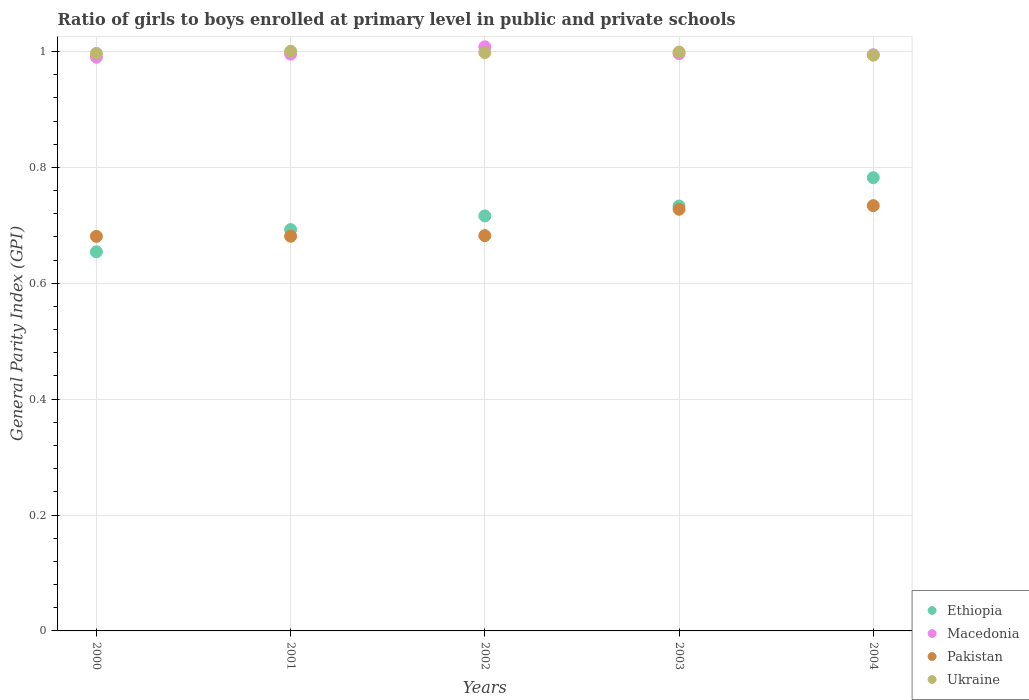Is the number of dotlines equal to the number of legend labels?
Offer a very short reply. Yes. What is the general parity index in Pakistan in 2004?
Provide a short and direct response. 0.73. Across all years, what is the maximum general parity index in Pakistan?
Your answer should be very brief. 0.73. Across all years, what is the minimum general parity index in Pakistan?
Provide a succinct answer. 0.68. In which year was the general parity index in Ethiopia maximum?
Ensure brevity in your answer.  2004. In which year was the general parity index in Pakistan minimum?
Make the answer very short. 2000. What is the total general parity index in Ethiopia in the graph?
Ensure brevity in your answer.  3.58. What is the difference between the general parity index in Ethiopia in 2000 and that in 2003?
Provide a short and direct response. -0.08. What is the difference between the general parity index in Macedonia in 2002 and the general parity index in Ethiopia in 2003?
Offer a very short reply. 0.27. What is the average general parity index in Ethiopia per year?
Your answer should be compact. 0.72. In the year 2001, what is the difference between the general parity index in Ethiopia and general parity index in Macedonia?
Provide a short and direct response. -0.3. What is the ratio of the general parity index in Ethiopia in 2000 to that in 2001?
Offer a terse response. 0.94. Is the difference between the general parity index in Ethiopia in 2000 and 2004 greater than the difference between the general parity index in Macedonia in 2000 and 2004?
Offer a terse response. No. What is the difference between the highest and the second highest general parity index in Macedonia?
Offer a very short reply. 0.01. What is the difference between the highest and the lowest general parity index in Pakistan?
Ensure brevity in your answer.  0.05. Is it the case that in every year, the sum of the general parity index in Pakistan and general parity index in Macedonia  is greater than the sum of general parity index in Ukraine and general parity index in Ethiopia?
Make the answer very short. No. Is the general parity index in Pakistan strictly greater than the general parity index in Macedonia over the years?
Your response must be concise. No. Is the general parity index in Ethiopia strictly less than the general parity index in Pakistan over the years?
Your answer should be compact. No. How many dotlines are there?
Your response must be concise. 4. What is the difference between two consecutive major ticks on the Y-axis?
Your response must be concise. 0.2. Where does the legend appear in the graph?
Your response must be concise. Bottom right. How many legend labels are there?
Ensure brevity in your answer.  4. How are the legend labels stacked?
Make the answer very short. Vertical. What is the title of the graph?
Offer a very short reply. Ratio of girls to boys enrolled at primary level in public and private schools. Does "Comoros" appear as one of the legend labels in the graph?
Your response must be concise. No. What is the label or title of the X-axis?
Make the answer very short. Years. What is the label or title of the Y-axis?
Offer a very short reply. General Parity Index (GPI). What is the General Parity Index (GPI) of Ethiopia in 2000?
Give a very brief answer. 0.65. What is the General Parity Index (GPI) in Macedonia in 2000?
Keep it short and to the point. 0.99. What is the General Parity Index (GPI) of Pakistan in 2000?
Offer a very short reply. 0.68. What is the General Parity Index (GPI) in Ukraine in 2000?
Ensure brevity in your answer.  1. What is the General Parity Index (GPI) of Ethiopia in 2001?
Keep it short and to the point. 0.69. What is the General Parity Index (GPI) of Macedonia in 2001?
Make the answer very short. 1. What is the General Parity Index (GPI) in Pakistan in 2001?
Your response must be concise. 0.68. What is the General Parity Index (GPI) in Ukraine in 2001?
Your answer should be very brief. 1. What is the General Parity Index (GPI) of Ethiopia in 2002?
Offer a terse response. 0.72. What is the General Parity Index (GPI) in Macedonia in 2002?
Your answer should be compact. 1.01. What is the General Parity Index (GPI) in Pakistan in 2002?
Provide a succinct answer. 0.68. What is the General Parity Index (GPI) in Ukraine in 2002?
Provide a succinct answer. 1. What is the General Parity Index (GPI) of Ethiopia in 2003?
Keep it short and to the point. 0.73. What is the General Parity Index (GPI) of Macedonia in 2003?
Your answer should be compact. 1. What is the General Parity Index (GPI) of Pakistan in 2003?
Give a very brief answer. 0.73. What is the General Parity Index (GPI) in Ukraine in 2003?
Ensure brevity in your answer.  1. What is the General Parity Index (GPI) in Ethiopia in 2004?
Make the answer very short. 0.78. What is the General Parity Index (GPI) in Macedonia in 2004?
Keep it short and to the point. 0.99. What is the General Parity Index (GPI) in Pakistan in 2004?
Your response must be concise. 0.73. What is the General Parity Index (GPI) in Ukraine in 2004?
Your answer should be compact. 0.99. Across all years, what is the maximum General Parity Index (GPI) in Ethiopia?
Ensure brevity in your answer.  0.78. Across all years, what is the maximum General Parity Index (GPI) in Macedonia?
Your answer should be very brief. 1.01. Across all years, what is the maximum General Parity Index (GPI) in Pakistan?
Make the answer very short. 0.73. Across all years, what is the maximum General Parity Index (GPI) in Ukraine?
Provide a succinct answer. 1. Across all years, what is the minimum General Parity Index (GPI) of Ethiopia?
Ensure brevity in your answer.  0.65. Across all years, what is the minimum General Parity Index (GPI) in Macedonia?
Offer a terse response. 0.99. Across all years, what is the minimum General Parity Index (GPI) in Pakistan?
Offer a very short reply. 0.68. Across all years, what is the minimum General Parity Index (GPI) in Ukraine?
Give a very brief answer. 0.99. What is the total General Parity Index (GPI) in Ethiopia in the graph?
Ensure brevity in your answer.  3.58. What is the total General Parity Index (GPI) of Macedonia in the graph?
Make the answer very short. 4.98. What is the total General Parity Index (GPI) of Pakistan in the graph?
Provide a short and direct response. 3.51. What is the total General Parity Index (GPI) of Ukraine in the graph?
Provide a succinct answer. 4.99. What is the difference between the General Parity Index (GPI) of Ethiopia in 2000 and that in 2001?
Provide a succinct answer. -0.04. What is the difference between the General Parity Index (GPI) in Macedonia in 2000 and that in 2001?
Make the answer very short. -0.01. What is the difference between the General Parity Index (GPI) in Pakistan in 2000 and that in 2001?
Provide a succinct answer. -0. What is the difference between the General Parity Index (GPI) in Ukraine in 2000 and that in 2001?
Provide a succinct answer. -0. What is the difference between the General Parity Index (GPI) in Ethiopia in 2000 and that in 2002?
Make the answer very short. -0.06. What is the difference between the General Parity Index (GPI) in Macedonia in 2000 and that in 2002?
Keep it short and to the point. -0.02. What is the difference between the General Parity Index (GPI) of Pakistan in 2000 and that in 2002?
Your answer should be compact. -0. What is the difference between the General Parity Index (GPI) of Ukraine in 2000 and that in 2002?
Offer a terse response. -0. What is the difference between the General Parity Index (GPI) in Ethiopia in 2000 and that in 2003?
Provide a succinct answer. -0.08. What is the difference between the General Parity Index (GPI) of Macedonia in 2000 and that in 2003?
Offer a terse response. -0.01. What is the difference between the General Parity Index (GPI) in Pakistan in 2000 and that in 2003?
Provide a short and direct response. -0.05. What is the difference between the General Parity Index (GPI) in Ukraine in 2000 and that in 2003?
Make the answer very short. -0. What is the difference between the General Parity Index (GPI) in Ethiopia in 2000 and that in 2004?
Your answer should be compact. -0.13. What is the difference between the General Parity Index (GPI) in Macedonia in 2000 and that in 2004?
Provide a succinct answer. -0. What is the difference between the General Parity Index (GPI) of Pakistan in 2000 and that in 2004?
Offer a very short reply. -0.05. What is the difference between the General Parity Index (GPI) of Ukraine in 2000 and that in 2004?
Ensure brevity in your answer.  0. What is the difference between the General Parity Index (GPI) in Ethiopia in 2001 and that in 2002?
Your response must be concise. -0.02. What is the difference between the General Parity Index (GPI) of Macedonia in 2001 and that in 2002?
Provide a short and direct response. -0.01. What is the difference between the General Parity Index (GPI) of Pakistan in 2001 and that in 2002?
Ensure brevity in your answer.  -0. What is the difference between the General Parity Index (GPI) of Ukraine in 2001 and that in 2002?
Give a very brief answer. 0. What is the difference between the General Parity Index (GPI) of Ethiopia in 2001 and that in 2003?
Your response must be concise. -0.04. What is the difference between the General Parity Index (GPI) in Macedonia in 2001 and that in 2003?
Your answer should be very brief. -0. What is the difference between the General Parity Index (GPI) of Pakistan in 2001 and that in 2003?
Make the answer very short. -0.05. What is the difference between the General Parity Index (GPI) of Ukraine in 2001 and that in 2003?
Your answer should be compact. 0. What is the difference between the General Parity Index (GPI) of Ethiopia in 2001 and that in 2004?
Your answer should be very brief. -0.09. What is the difference between the General Parity Index (GPI) in Macedonia in 2001 and that in 2004?
Your response must be concise. 0. What is the difference between the General Parity Index (GPI) in Pakistan in 2001 and that in 2004?
Ensure brevity in your answer.  -0.05. What is the difference between the General Parity Index (GPI) of Ukraine in 2001 and that in 2004?
Provide a succinct answer. 0.01. What is the difference between the General Parity Index (GPI) of Ethiopia in 2002 and that in 2003?
Your answer should be very brief. -0.02. What is the difference between the General Parity Index (GPI) of Macedonia in 2002 and that in 2003?
Make the answer very short. 0.01. What is the difference between the General Parity Index (GPI) in Pakistan in 2002 and that in 2003?
Your answer should be very brief. -0.05. What is the difference between the General Parity Index (GPI) of Ukraine in 2002 and that in 2003?
Offer a terse response. -0. What is the difference between the General Parity Index (GPI) in Ethiopia in 2002 and that in 2004?
Provide a short and direct response. -0.07. What is the difference between the General Parity Index (GPI) of Macedonia in 2002 and that in 2004?
Offer a terse response. 0.01. What is the difference between the General Parity Index (GPI) in Pakistan in 2002 and that in 2004?
Provide a succinct answer. -0.05. What is the difference between the General Parity Index (GPI) in Ukraine in 2002 and that in 2004?
Your response must be concise. 0. What is the difference between the General Parity Index (GPI) of Ethiopia in 2003 and that in 2004?
Make the answer very short. -0.05. What is the difference between the General Parity Index (GPI) of Macedonia in 2003 and that in 2004?
Your answer should be very brief. 0. What is the difference between the General Parity Index (GPI) in Pakistan in 2003 and that in 2004?
Keep it short and to the point. -0.01. What is the difference between the General Parity Index (GPI) of Ukraine in 2003 and that in 2004?
Keep it short and to the point. 0.01. What is the difference between the General Parity Index (GPI) of Ethiopia in 2000 and the General Parity Index (GPI) of Macedonia in 2001?
Offer a terse response. -0.34. What is the difference between the General Parity Index (GPI) of Ethiopia in 2000 and the General Parity Index (GPI) of Pakistan in 2001?
Provide a succinct answer. -0.03. What is the difference between the General Parity Index (GPI) in Ethiopia in 2000 and the General Parity Index (GPI) in Ukraine in 2001?
Provide a succinct answer. -0.35. What is the difference between the General Parity Index (GPI) of Macedonia in 2000 and the General Parity Index (GPI) of Pakistan in 2001?
Offer a terse response. 0.31. What is the difference between the General Parity Index (GPI) in Macedonia in 2000 and the General Parity Index (GPI) in Ukraine in 2001?
Your answer should be compact. -0.01. What is the difference between the General Parity Index (GPI) in Pakistan in 2000 and the General Parity Index (GPI) in Ukraine in 2001?
Make the answer very short. -0.32. What is the difference between the General Parity Index (GPI) in Ethiopia in 2000 and the General Parity Index (GPI) in Macedonia in 2002?
Provide a succinct answer. -0.35. What is the difference between the General Parity Index (GPI) of Ethiopia in 2000 and the General Parity Index (GPI) of Pakistan in 2002?
Provide a short and direct response. -0.03. What is the difference between the General Parity Index (GPI) of Ethiopia in 2000 and the General Parity Index (GPI) of Ukraine in 2002?
Provide a succinct answer. -0.34. What is the difference between the General Parity Index (GPI) of Macedonia in 2000 and the General Parity Index (GPI) of Pakistan in 2002?
Make the answer very short. 0.31. What is the difference between the General Parity Index (GPI) of Macedonia in 2000 and the General Parity Index (GPI) of Ukraine in 2002?
Keep it short and to the point. -0.01. What is the difference between the General Parity Index (GPI) in Pakistan in 2000 and the General Parity Index (GPI) in Ukraine in 2002?
Offer a terse response. -0.32. What is the difference between the General Parity Index (GPI) in Ethiopia in 2000 and the General Parity Index (GPI) in Macedonia in 2003?
Your response must be concise. -0.34. What is the difference between the General Parity Index (GPI) of Ethiopia in 2000 and the General Parity Index (GPI) of Pakistan in 2003?
Provide a succinct answer. -0.07. What is the difference between the General Parity Index (GPI) in Ethiopia in 2000 and the General Parity Index (GPI) in Ukraine in 2003?
Ensure brevity in your answer.  -0.34. What is the difference between the General Parity Index (GPI) of Macedonia in 2000 and the General Parity Index (GPI) of Pakistan in 2003?
Keep it short and to the point. 0.26. What is the difference between the General Parity Index (GPI) in Macedonia in 2000 and the General Parity Index (GPI) in Ukraine in 2003?
Offer a very short reply. -0.01. What is the difference between the General Parity Index (GPI) in Pakistan in 2000 and the General Parity Index (GPI) in Ukraine in 2003?
Your answer should be very brief. -0.32. What is the difference between the General Parity Index (GPI) of Ethiopia in 2000 and the General Parity Index (GPI) of Macedonia in 2004?
Your answer should be compact. -0.34. What is the difference between the General Parity Index (GPI) of Ethiopia in 2000 and the General Parity Index (GPI) of Pakistan in 2004?
Keep it short and to the point. -0.08. What is the difference between the General Parity Index (GPI) of Ethiopia in 2000 and the General Parity Index (GPI) of Ukraine in 2004?
Keep it short and to the point. -0.34. What is the difference between the General Parity Index (GPI) of Macedonia in 2000 and the General Parity Index (GPI) of Pakistan in 2004?
Provide a succinct answer. 0.26. What is the difference between the General Parity Index (GPI) of Macedonia in 2000 and the General Parity Index (GPI) of Ukraine in 2004?
Your response must be concise. -0. What is the difference between the General Parity Index (GPI) in Pakistan in 2000 and the General Parity Index (GPI) in Ukraine in 2004?
Keep it short and to the point. -0.31. What is the difference between the General Parity Index (GPI) in Ethiopia in 2001 and the General Parity Index (GPI) in Macedonia in 2002?
Provide a short and direct response. -0.32. What is the difference between the General Parity Index (GPI) of Ethiopia in 2001 and the General Parity Index (GPI) of Pakistan in 2002?
Offer a very short reply. 0.01. What is the difference between the General Parity Index (GPI) in Ethiopia in 2001 and the General Parity Index (GPI) in Ukraine in 2002?
Give a very brief answer. -0.31. What is the difference between the General Parity Index (GPI) in Macedonia in 2001 and the General Parity Index (GPI) in Pakistan in 2002?
Offer a very short reply. 0.31. What is the difference between the General Parity Index (GPI) in Macedonia in 2001 and the General Parity Index (GPI) in Ukraine in 2002?
Your answer should be compact. -0. What is the difference between the General Parity Index (GPI) in Pakistan in 2001 and the General Parity Index (GPI) in Ukraine in 2002?
Keep it short and to the point. -0.32. What is the difference between the General Parity Index (GPI) of Ethiopia in 2001 and the General Parity Index (GPI) of Macedonia in 2003?
Your response must be concise. -0.3. What is the difference between the General Parity Index (GPI) in Ethiopia in 2001 and the General Parity Index (GPI) in Pakistan in 2003?
Your answer should be compact. -0.04. What is the difference between the General Parity Index (GPI) of Ethiopia in 2001 and the General Parity Index (GPI) of Ukraine in 2003?
Your response must be concise. -0.31. What is the difference between the General Parity Index (GPI) of Macedonia in 2001 and the General Parity Index (GPI) of Pakistan in 2003?
Offer a terse response. 0.27. What is the difference between the General Parity Index (GPI) in Macedonia in 2001 and the General Parity Index (GPI) in Ukraine in 2003?
Your answer should be very brief. -0. What is the difference between the General Parity Index (GPI) in Pakistan in 2001 and the General Parity Index (GPI) in Ukraine in 2003?
Offer a very short reply. -0.32. What is the difference between the General Parity Index (GPI) of Ethiopia in 2001 and the General Parity Index (GPI) of Macedonia in 2004?
Provide a succinct answer. -0.3. What is the difference between the General Parity Index (GPI) in Ethiopia in 2001 and the General Parity Index (GPI) in Pakistan in 2004?
Offer a very short reply. -0.04. What is the difference between the General Parity Index (GPI) in Ethiopia in 2001 and the General Parity Index (GPI) in Ukraine in 2004?
Give a very brief answer. -0.3. What is the difference between the General Parity Index (GPI) in Macedonia in 2001 and the General Parity Index (GPI) in Pakistan in 2004?
Your answer should be very brief. 0.26. What is the difference between the General Parity Index (GPI) in Macedonia in 2001 and the General Parity Index (GPI) in Ukraine in 2004?
Give a very brief answer. 0. What is the difference between the General Parity Index (GPI) of Pakistan in 2001 and the General Parity Index (GPI) of Ukraine in 2004?
Give a very brief answer. -0.31. What is the difference between the General Parity Index (GPI) in Ethiopia in 2002 and the General Parity Index (GPI) in Macedonia in 2003?
Your answer should be very brief. -0.28. What is the difference between the General Parity Index (GPI) in Ethiopia in 2002 and the General Parity Index (GPI) in Pakistan in 2003?
Provide a short and direct response. -0.01. What is the difference between the General Parity Index (GPI) in Ethiopia in 2002 and the General Parity Index (GPI) in Ukraine in 2003?
Make the answer very short. -0.28. What is the difference between the General Parity Index (GPI) of Macedonia in 2002 and the General Parity Index (GPI) of Pakistan in 2003?
Your answer should be compact. 0.28. What is the difference between the General Parity Index (GPI) of Macedonia in 2002 and the General Parity Index (GPI) of Ukraine in 2003?
Keep it short and to the point. 0.01. What is the difference between the General Parity Index (GPI) in Pakistan in 2002 and the General Parity Index (GPI) in Ukraine in 2003?
Your answer should be compact. -0.32. What is the difference between the General Parity Index (GPI) in Ethiopia in 2002 and the General Parity Index (GPI) in Macedonia in 2004?
Your response must be concise. -0.28. What is the difference between the General Parity Index (GPI) in Ethiopia in 2002 and the General Parity Index (GPI) in Pakistan in 2004?
Your response must be concise. -0.02. What is the difference between the General Parity Index (GPI) in Ethiopia in 2002 and the General Parity Index (GPI) in Ukraine in 2004?
Give a very brief answer. -0.28. What is the difference between the General Parity Index (GPI) of Macedonia in 2002 and the General Parity Index (GPI) of Pakistan in 2004?
Offer a very short reply. 0.27. What is the difference between the General Parity Index (GPI) of Macedonia in 2002 and the General Parity Index (GPI) of Ukraine in 2004?
Make the answer very short. 0.01. What is the difference between the General Parity Index (GPI) of Pakistan in 2002 and the General Parity Index (GPI) of Ukraine in 2004?
Give a very brief answer. -0.31. What is the difference between the General Parity Index (GPI) of Ethiopia in 2003 and the General Parity Index (GPI) of Macedonia in 2004?
Your response must be concise. -0.26. What is the difference between the General Parity Index (GPI) in Ethiopia in 2003 and the General Parity Index (GPI) in Pakistan in 2004?
Provide a short and direct response. -0. What is the difference between the General Parity Index (GPI) of Ethiopia in 2003 and the General Parity Index (GPI) of Ukraine in 2004?
Offer a very short reply. -0.26. What is the difference between the General Parity Index (GPI) of Macedonia in 2003 and the General Parity Index (GPI) of Pakistan in 2004?
Provide a succinct answer. 0.26. What is the difference between the General Parity Index (GPI) in Macedonia in 2003 and the General Parity Index (GPI) in Ukraine in 2004?
Your answer should be compact. 0. What is the difference between the General Parity Index (GPI) in Pakistan in 2003 and the General Parity Index (GPI) in Ukraine in 2004?
Give a very brief answer. -0.27. What is the average General Parity Index (GPI) of Ethiopia per year?
Ensure brevity in your answer.  0.72. What is the average General Parity Index (GPI) in Macedonia per year?
Keep it short and to the point. 1. What is the average General Parity Index (GPI) in Pakistan per year?
Keep it short and to the point. 0.7. What is the average General Parity Index (GPI) of Ukraine per year?
Provide a short and direct response. 1. In the year 2000, what is the difference between the General Parity Index (GPI) of Ethiopia and General Parity Index (GPI) of Macedonia?
Your answer should be very brief. -0.34. In the year 2000, what is the difference between the General Parity Index (GPI) in Ethiopia and General Parity Index (GPI) in Pakistan?
Make the answer very short. -0.03. In the year 2000, what is the difference between the General Parity Index (GPI) in Ethiopia and General Parity Index (GPI) in Ukraine?
Your answer should be compact. -0.34. In the year 2000, what is the difference between the General Parity Index (GPI) in Macedonia and General Parity Index (GPI) in Pakistan?
Your answer should be compact. 0.31. In the year 2000, what is the difference between the General Parity Index (GPI) in Macedonia and General Parity Index (GPI) in Ukraine?
Provide a succinct answer. -0.01. In the year 2000, what is the difference between the General Parity Index (GPI) in Pakistan and General Parity Index (GPI) in Ukraine?
Your answer should be very brief. -0.32. In the year 2001, what is the difference between the General Parity Index (GPI) of Ethiopia and General Parity Index (GPI) of Macedonia?
Make the answer very short. -0.3. In the year 2001, what is the difference between the General Parity Index (GPI) of Ethiopia and General Parity Index (GPI) of Pakistan?
Your response must be concise. 0.01. In the year 2001, what is the difference between the General Parity Index (GPI) in Ethiopia and General Parity Index (GPI) in Ukraine?
Ensure brevity in your answer.  -0.31. In the year 2001, what is the difference between the General Parity Index (GPI) in Macedonia and General Parity Index (GPI) in Pakistan?
Ensure brevity in your answer.  0.31. In the year 2001, what is the difference between the General Parity Index (GPI) of Macedonia and General Parity Index (GPI) of Ukraine?
Keep it short and to the point. -0.01. In the year 2001, what is the difference between the General Parity Index (GPI) of Pakistan and General Parity Index (GPI) of Ukraine?
Your answer should be very brief. -0.32. In the year 2002, what is the difference between the General Parity Index (GPI) of Ethiopia and General Parity Index (GPI) of Macedonia?
Make the answer very short. -0.29. In the year 2002, what is the difference between the General Parity Index (GPI) in Ethiopia and General Parity Index (GPI) in Pakistan?
Provide a succinct answer. 0.03. In the year 2002, what is the difference between the General Parity Index (GPI) of Ethiopia and General Parity Index (GPI) of Ukraine?
Offer a terse response. -0.28. In the year 2002, what is the difference between the General Parity Index (GPI) of Macedonia and General Parity Index (GPI) of Pakistan?
Offer a terse response. 0.33. In the year 2002, what is the difference between the General Parity Index (GPI) of Macedonia and General Parity Index (GPI) of Ukraine?
Your response must be concise. 0.01. In the year 2002, what is the difference between the General Parity Index (GPI) in Pakistan and General Parity Index (GPI) in Ukraine?
Your answer should be compact. -0.32. In the year 2003, what is the difference between the General Parity Index (GPI) in Ethiopia and General Parity Index (GPI) in Macedonia?
Provide a short and direct response. -0.26. In the year 2003, what is the difference between the General Parity Index (GPI) in Ethiopia and General Parity Index (GPI) in Pakistan?
Provide a succinct answer. 0.01. In the year 2003, what is the difference between the General Parity Index (GPI) in Ethiopia and General Parity Index (GPI) in Ukraine?
Make the answer very short. -0.27. In the year 2003, what is the difference between the General Parity Index (GPI) in Macedonia and General Parity Index (GPI) in Pakistan?
Your response must be concise. 0.27. In the year 2003, what is the difference between the General Parity Index (GPI) in Macedonia and General Parity Index (GPI) in Ukraine?
Your response must be concise. -0. In the year 2003, what is the difference between the General Parity Index (GPI) of Pakistan and General Parity Index (GPI) of Ukraine?
Your answer should be very brief. -0.27. In the year 2004, what is the difference between the General Parity Index (GPI) in Ethiopia and General Parity Index (GPI) in Macedonia?
Provide a short and direct response. -0.21. In the year 2004, what is the difference between the General Parity Index (GPI) of Ethiopia and General Parity Index (GPI) of Pakistan?
Make the answer very short. 0.05. In the year 2004, what is the difference between the General Parity Index (GPI) of Ethiopia and General Parity Index (GPI) of Ukraine?
Offer a very short reply. -0.21. In the year 2004, what is the difference between the General Parity Index (GPI) of Macedonia and General Parity Index (GPI) of Pakistan?
Ensure brevity in your answer.  0.26. In the year 2004, what is the difference between the General Parity Index (GPI) in Macedonia and General Parity Index (GPI) in Ukraine?
Provide a short and direct response. 0. In the year 2004, what is the difference between the General Parity Index (GPI) of Pakistan and General Parity Index (GPI) of Ukraine?
Your response must be concise. -0.26. What is the ratio of the General Parity Index (GPI) of Ethiopia in 2000 to that in 2001?
Your response must be concise. 0.94. What is the ratio of the General Parity Index (GPI) of Pakistan in 2000 to that in 2001?
Make the answer very short. 1. What is the ratio of the General Parity Index (GPI) in Ukraine in 2000 to that in 2001?
Keep it short and to the point. 1. What is the ratio of the General Parity Index (GPI) of Ethiopia in 2000 to that in 2002?
Offer a very short reply. 0.91. What is the ratio of the General Parity Index (GPI) in Macedonia in 2000 to that in 2002?
Make the answer very short. 0.98. What is the ratio of the General Parity Index (GPI) in Ethiopia in 2000 to that in 2003?
Your response must be concise. 0.89. What is the ratio of the General Parity Index (GPI) of Pakistan in 2000 to that in 2003?
Provide a short and direct response. 0.94. What is the ratio of the General Parity Index (GPI) of Ukraine in 2000 to that in 2003?
Your response must be concise. 1. What is the ratio of the General Parity Index (GPI) in Ethiopia in 2000 to that in 2004?
Offer a very short reply. 0.84. What is the ratio of the General Parity Index (GPI) of Macedonia in 2000 to that in 2004?
Your answer should be very brief. 1. What is the ratio of the General Parity Index (GPI) of Pakistan in 2000 to that in 2004?
Give a very brief answer. 0.93. What is the ratio of the General Parity Index (GPI) of Ethiopia in 2001 to that in 2002?
Keep it short and to the point. 0.97. What is the ratio of the General Parity Index (GPI) in Macedonia in 2001 to that in 2002?
Make the answer very short. 0.99. What is the ratio of the General Parity Index (GPI) of Pakistan in 2001 to that in 2002?
Provide a succinct answer. 1. What is the ratio of the General Parity Index (GPI) in Ethiopia in 2001 to that in 2003?
Make the answer very short. 0.94. What is the ratio of the General Parity Index (GPI) in Macedonia in 2001 to that in 2003?
Provide a short and direct response. 1. What is the ratio of the General Parity Index (GPI) of Pakistan in 2001 to that in 2003?
Your answer should be compact. 0.94. What is the ratio of the General Parity Index (GPI) in Ethiopia in 2001 to that in 2004?
Offer a terse response. 0.89. What is the ratio of the General Parity Index (GPI) of Pakistan in 2001 to that in 2004?
Your response must be concise. 0.93. What is the ratio of the General Parity Index (GPI) in Ukraine in 2001 to that in 2004?
Your response must be concise. 1.01. What is the ratio of the General Parity Index (GPI) of Ethiopia in 2002 to that in 2003?
Make the answer very short. 0.98. What is the ratio of the General Parity Index (GPI) of Macedonia in 2002 to that in 2003?
Offer a terse response. 1.01. What is the ratio of the General Parity Index (GPI) in Ethiopia in 2002 to that in 2004?
Your answer should be compact. 0.92. What is the ratio of the General Parity Index (GPI) of Macedonia in 2002 to that in 2004?
Your response must be concise. 1.01. What is the ratio of the General Parity Index (GPI) in Pakistan in 2002 to that in 2004?
Provide a short and direct response. 0.93. What is the ratio of the General Parity Index (GPI) of Ukraine in 2003 to that in 2004?
Make the answer very short. 1.01. What is the difference between the highest and the second highest General Parity Index (GPI) of Ethiopia?
Make the answer very short. 0.05. What is the difference between the highest and the second highest General Parity Index (GPI) in Macedonia?
Offer a terse response. 0.01. What is the difference between the highest and the second highest General Parity Index (GPI) in Pakistan?
Provide a short and direct response. 0.01. What is the difference between the highest and the second highest General Parity Index (GPI) of Ukraine?
Offer a terse response. 0. What is the difference between the highest and the lowest General Parity Index (GPI) of Ethiopia?
Provide a succinct answer. 0.13. What is the difference between the highest and the lowest General Parity Index (GPI) of Macedonia?
Your answer should be very brief. 0.02. What is the difference between the highest and the lowest General Parity Index (GPI) of Pakistan?
Give a very brief answer. 0.05. What is the difference between the highest and the lowest General Parity Index (GPI) in Ukraine?
Provide a succinct answer. 0.01. 